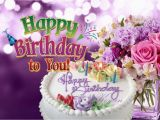What does the text on the image convey? The text on the image conveys birthday wishes. On the cake, 'Happy Birthday' is elegantly written in icing. Above the celebratory scene, the text 'Happy Birthday to You' floats in a playful and colorful font, reinforcing the festive greeting and the purpose of the image, which is to celebrate someone’s birthday. 